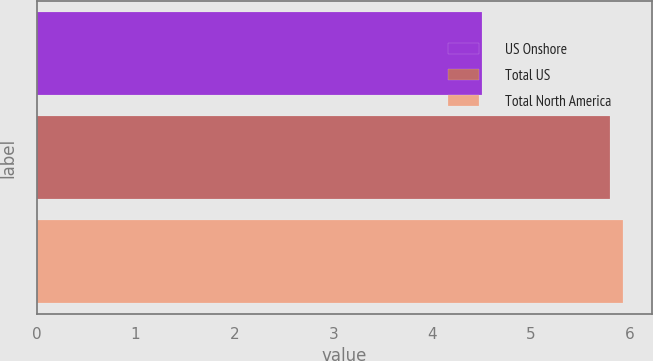<chart> <loc_0><loc_0><loc_500><loc_500><bar_chart><fcel>US Onshore<fcel>Total US<fcel>Total North America<nl><fcel>4.5<fcel>5.8<fcel>5.93<nl></chart> 